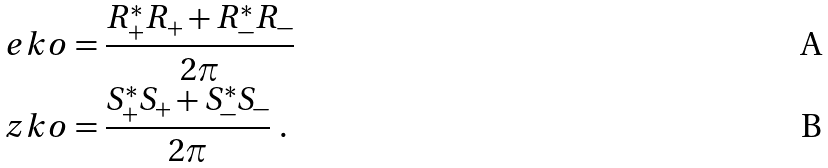Convert formula to latex. <formula><loc_0><loc_0><loc_500><loc_500>\ e k o & = \frac { R _ { + } ^ { * } R _ { + } + R _ { - } ^ { * } R _ { - } } { 2 \pi } \\ \ z k o & = \frac { S _ { + } ^ { * } S _ { + } + S _ { - } ^ { * } S _ { - } } { 2 \pi } \ .</formula> 